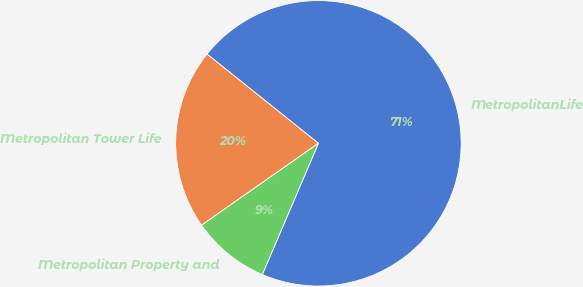Convert chart. <chart><loc_0><loc_0><loc_500><loc_500><pie_chart><fcel>MetropolitanLife<fcel>Metropolitan Tower Life<fcel>Metropolitan Property and<nl><fcel>70.69%<fcel>20.48%<fcel>8.84%<nl></chart> 